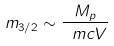Convert formula to latex. <formula><loc_0><loc_0><loc_500><loc_500>m _ { 3 / 2 } \sim \frac { M _ { p } } { \ m c { V } }</formula> 